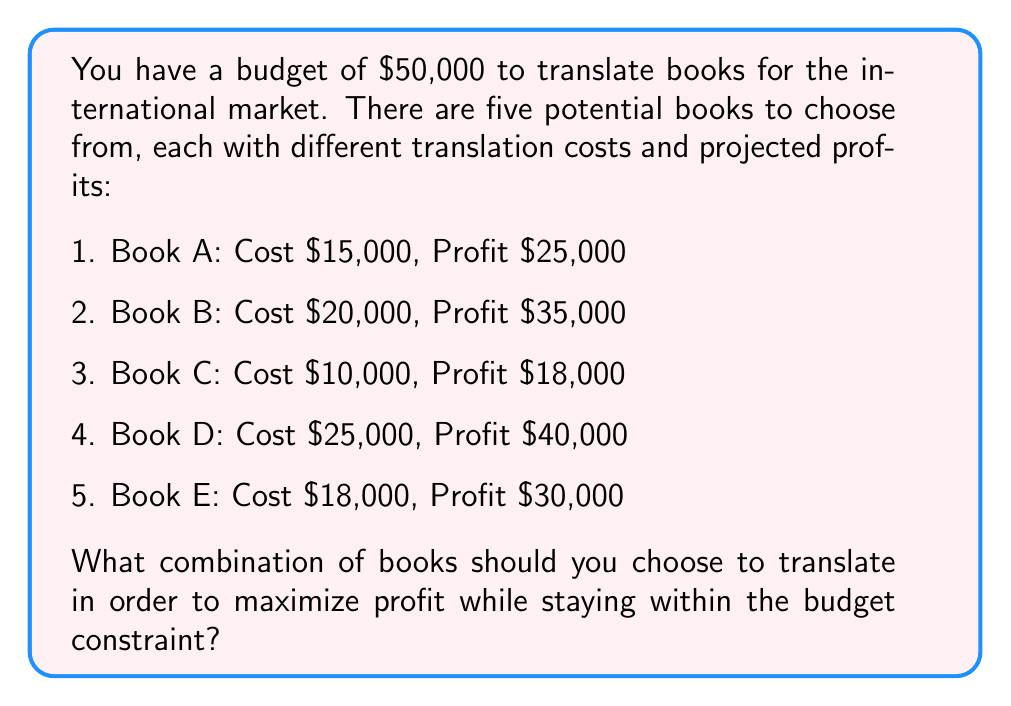Give your solution to this math problem. To solve this problem, we can use the concept of 0-1 Knapsack problem from Decision Theory. Let's approach this step-by-step:

1) First, let's define our variables:
   $x_i = \begin{cases} 1 & \text{if book i is selected} \\ 0 & \text{otherwise} \end{cases}$

2) Our objective function is to maximize profit:
   $\text{Maximize } 25000x_A + 35000x_B + 18000x_C + 40000x_D + 30000x_E$

3) Subject to the budget constraint:
   $15000x_A + 20000x_B + 10000x_C + 25000x_D + 18000x_E \leq 50000$

4) We can solve this using the branch and bound method, but for simplicity, let's use a greedy approach by calculating the profit-to-cost ratio for each book:

   A: $25000/15000 = 1.67$
   B: $35000/20000 = 1.75$
   C: $18000/10000 = 1.80$
   D: $40000/25000 = 1.60$
   E: $30000/18000 = 1.67$

5) Sorting by this ratio in descending order: C, B, A/E, D

6) Now, let's select books in this order until we exhaust our budget:
   - Select C: Cost $10,000, Remaining budget $40,000
   - Select B: Cost $20,000, Remaining budget $20,000
   - Select E: Cost $18,000, Remaining budget $2,000

7) We can't select any more books with the remaining budget.

8) Calculate total profit:
   $18000 + 35000 + 30000 = $83,000$

Therefore, the optimal combination is to translate books C, B, and E.
Answer: The optimal combination is to translate books C, B, and E, yielding a total profit of $83,000. 